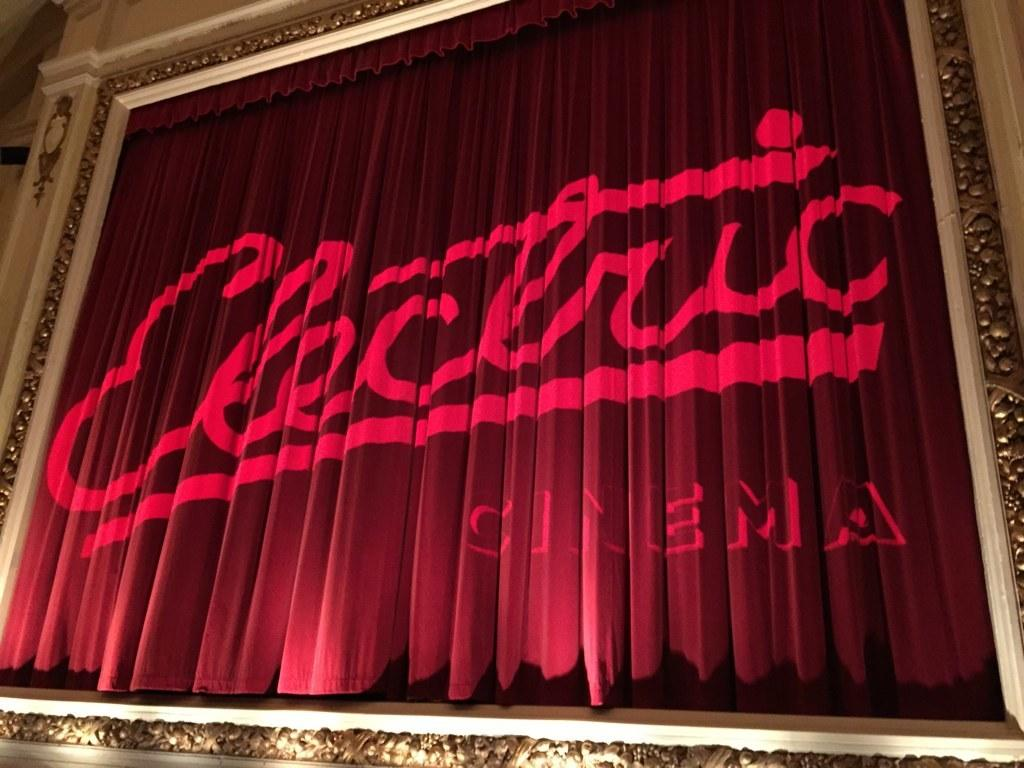What color is the curtain in the image? The curtain in the image is red. What is written or depicted on the curtain? There is text on the curtain. What can be seen on the left side of the image? There is a wall on the left side of the image. How many loaves of bread are stacked on the curtain in the image? There are no loaves of bread present in the image. What type of yam is being used as a decoration on the wall in the image? There is no yam present in the image, and the wall does not have any decorations. 